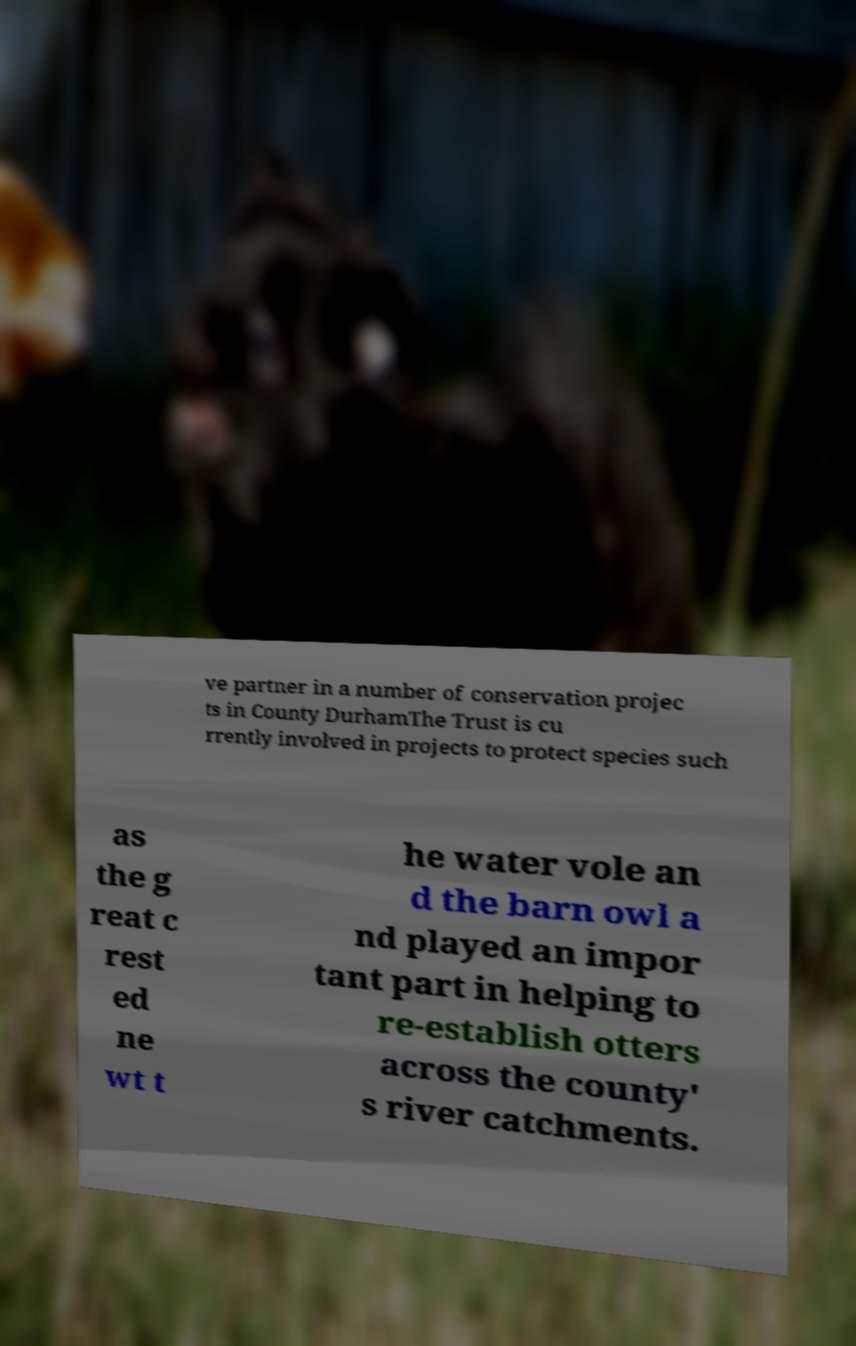There's text embedded in this image that I need extracted. Can you transcribe it verbatim? ve partner in a number of conservation projec ts in County DurhamThe Trust is cu rrently involved in projects to protect species such as the g reat c rest ed ne wt t he water vole an d the barn owl a nd played an impor tant part in helping to re-establish otters across the county' s river catchments. 